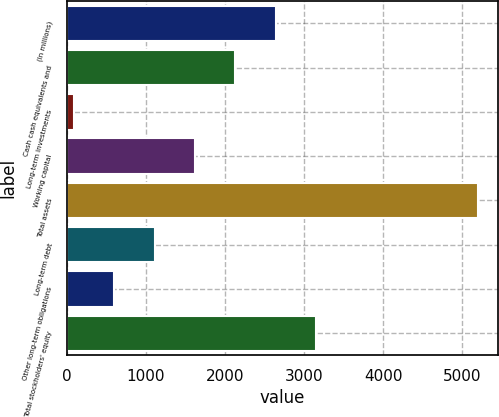Convert chart. <chart><loc_0><loc_0><loc_500><loc_500><bar_chart><fcel>(In millions)<fcel>Cash cash equivalents and<fcel>Long-term investments<fcel>Working capital<fcel>Total assets<fcel>Long-term debt<fcel>Other long-term obligations<fcel>Total stockholders' equity<nl><fcel>2644.5<fcel>2133.8<fcel>91<fcel>1623.1<fcel>5198<fcel>1112.4<fcel>601.7<fcel>3155.2<nl></chart> 